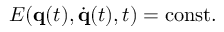Convert formula to latex. <formula><loc_0><loc_0><loc_500><loc_500>E ( q ( t ) , { \dot { q } } ( t ) , t ) = { c o n s t } .</formula> 